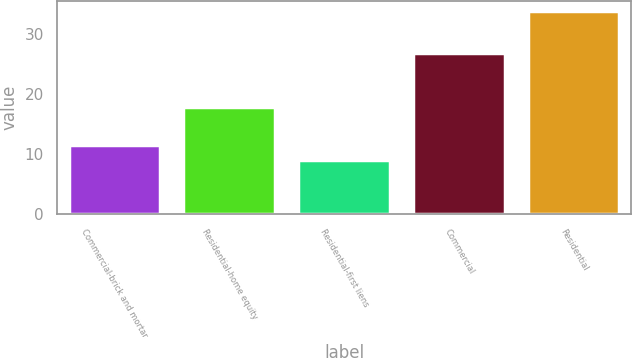Convert chart to OTSL. <chart><loc_0><loc_0><loc_500><loc_500><bar_chart><fcel>Commercial-brick and mortar<fcel>Residential-home equity<fcel>Residential-first liens<fcel>Commercial<fcel>Residential<nl><fcel>11.47<fcel>17.7<fcel>9<fcel>26.7<fcel>33.7<nl></chart> 